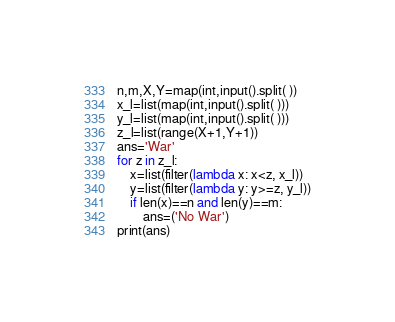<code> <loc_0><loc_0><loc_500><loc_500><_Python_>n,m,X,Y=map(int,input().split( ))
x_l=list(map(int,input().split( )))
y_l=list(map(int,input().split( )))
z_l=list(range(X+1,Y+1))
ans='War'
for z in z_l:
    x=list(filter(lambda x: x<z, x_l))
    y=list(filter(lambda y: y>=z, y_l))
    if len(x)==n and len(y)==m:
        ans=('No War')
print(ans)</code> 